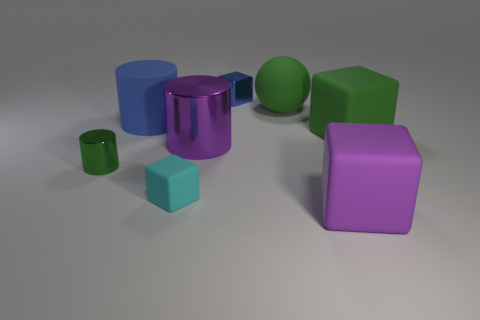What number of big purple rubber cubes are in front of the tiny shiny cylinder?
Your answer should be compact. 1. There is a sphere that is the same color as the small metal cylinder; what size is it?
Provide a short and direct response. Large. Are there any big matte objects of the same shape as the small green object?
Offer a terse response. Yes. The rubber ball that is the same size as the green block is what color?
Make the answer very short. Green. Are there fewer big blue matte things that are to the right of the ball than objects behind the large purple metal object?
Provide a succinct answer. Yes. Do the object that is in front of the cyan rubber thing and the green cylinder have the same size?
Your answer should be compact. No. There is a small shiny object that is left of the cyan block; what shape is it?
Make the answer very short. Cylinder. Are there more green matte objects than big rubber objects?
Your response must be concise. No. There is a tiny metal thing in front of the rubber cylinder; is its color the same as the big rubber ball?
Keep it short and to the point. Yes. What number of objects are either rubber cubes on the left side of the small blue object or matte things left of the shiny cube?
Make the answer very short. 2. 